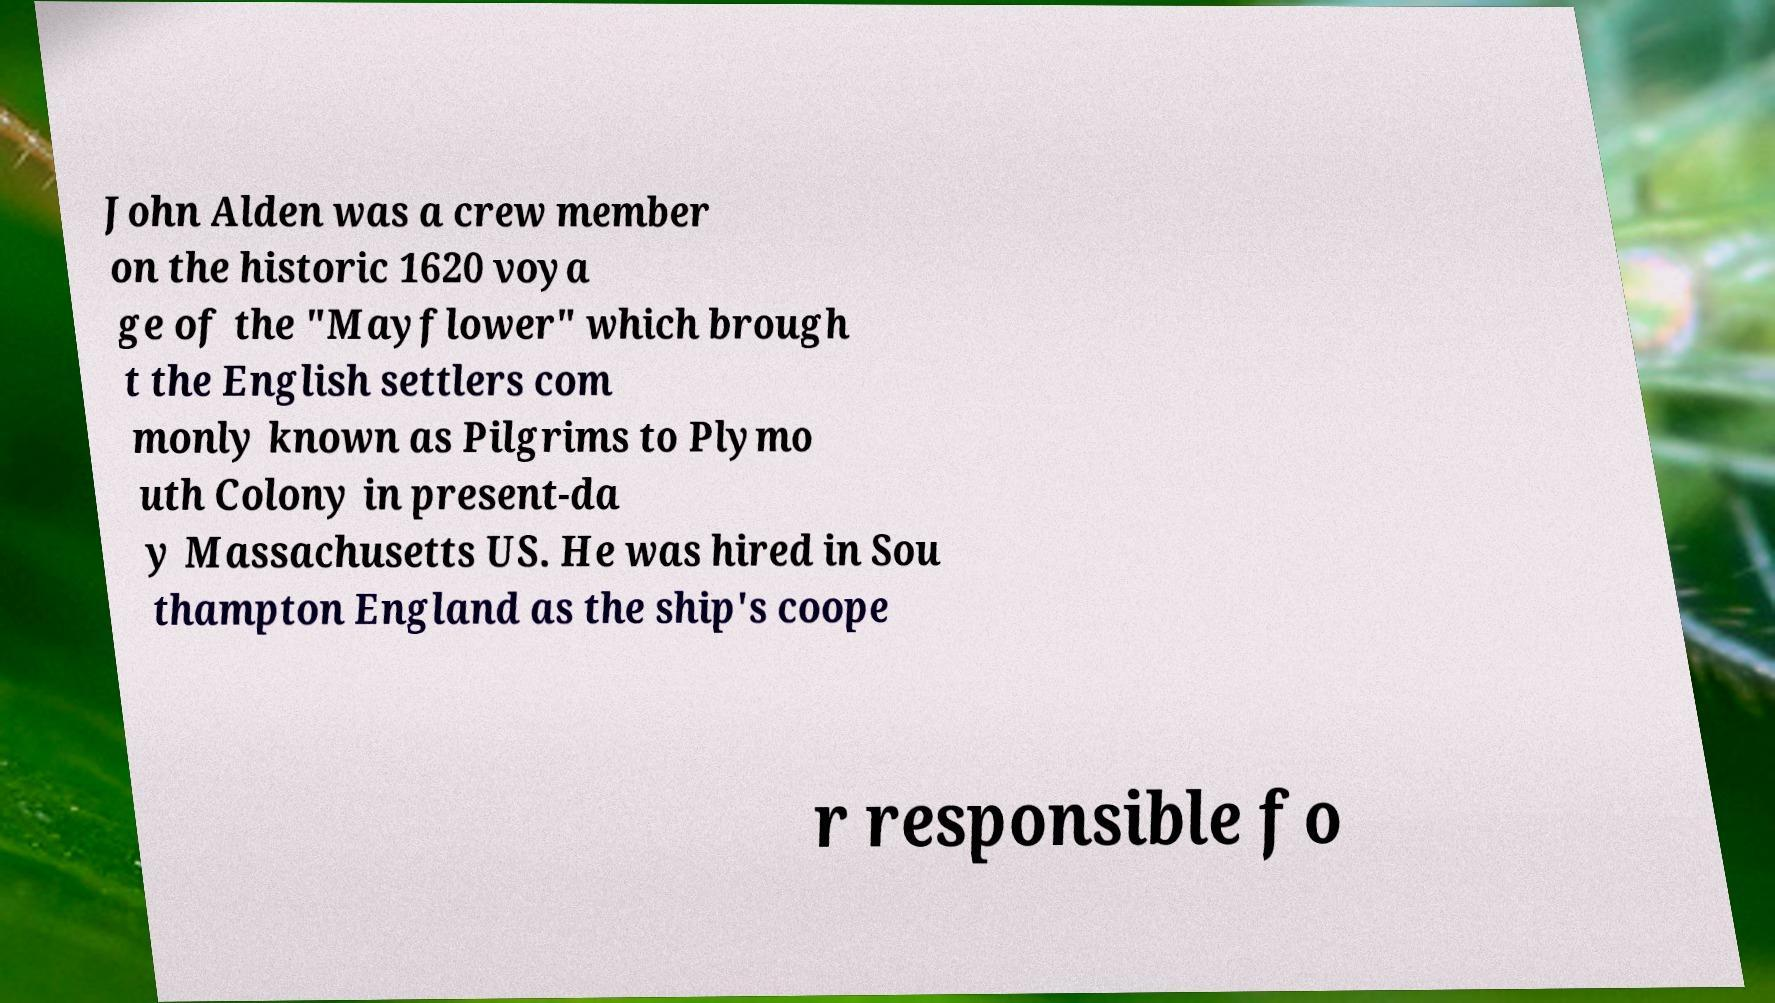Can you accurately transcribe the text from the provided image for me? John Alden was a crew member on the historic 1620 voya ge of the "Mayflower" which brough t the English settlers com monly known as Pilgrims to Plymo uth Colony in present-da y Massachusetts US. He was hired in Sou thampton England as the ship's coope r responsible fo 